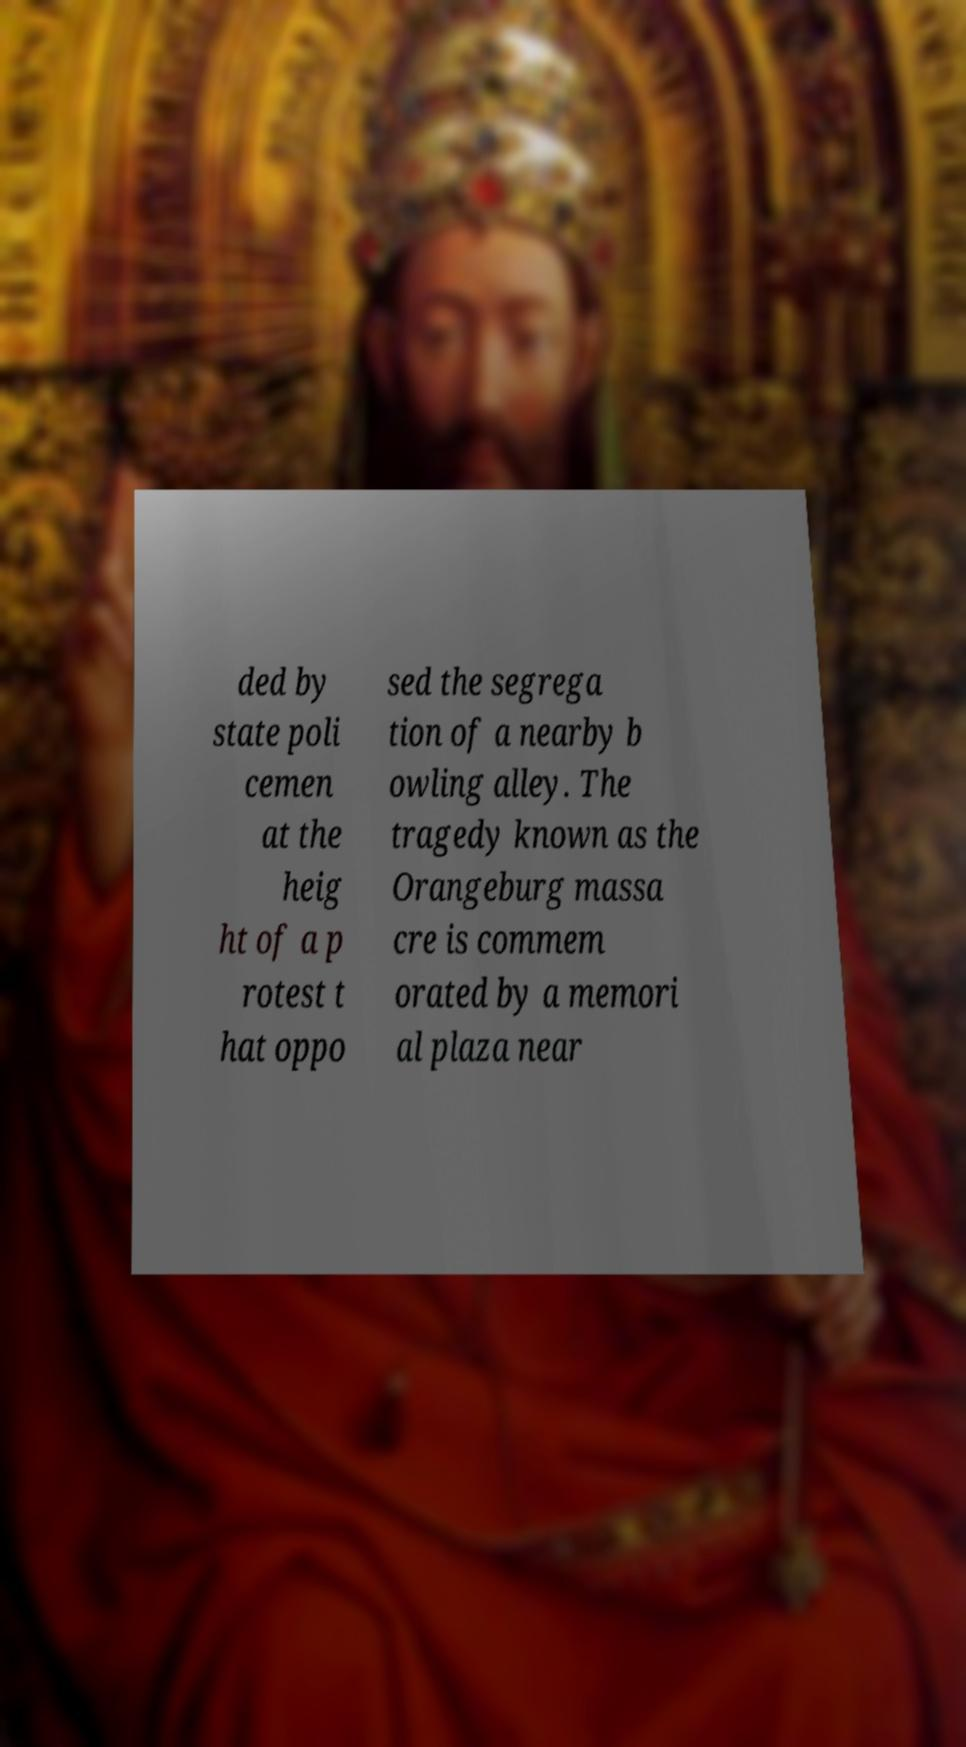For documentation purposes, I need the text within this image transcribed. Could you provide that? ded by state poli cemen at the heig ht of a p rotest t hat oppo sed the segrega tion of a nearby b owling alley. The tragedy known as the Orangeburg massa cre is commem orated by a memori al plaza near 